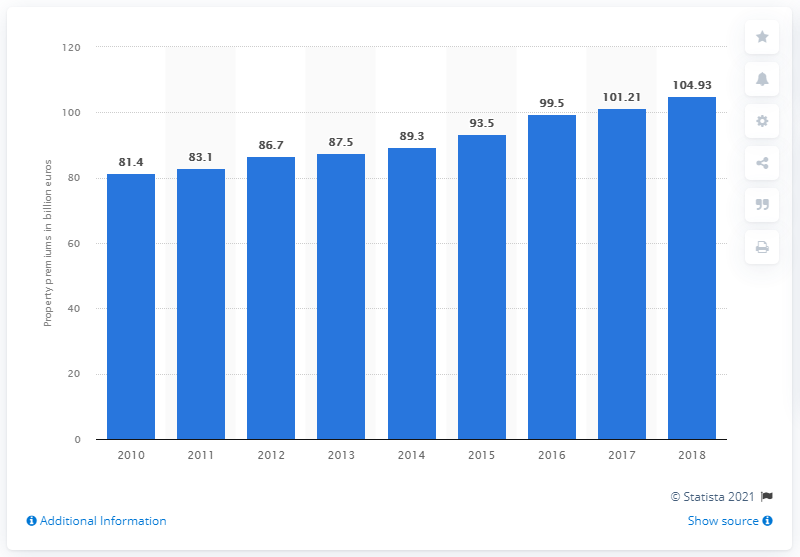Outline some significant characteristics in this image. In 2010, the value of property premiums on the European real estate market was 81.4 billion euros. The premiums for properties on the European real estate market reached a total of 104.93 in 2018. 